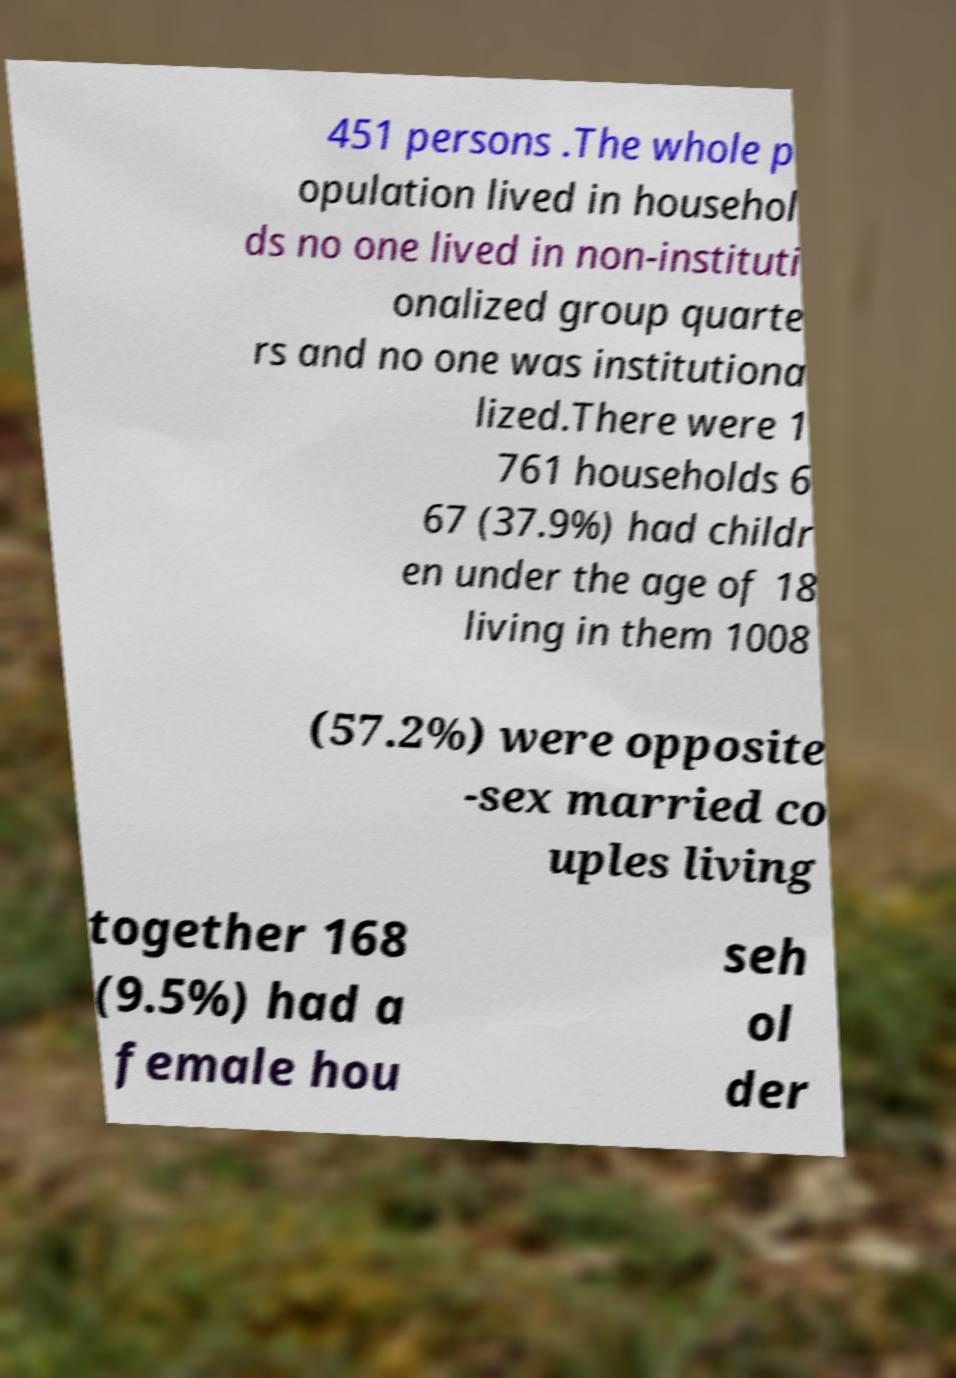Can you accurately transcribe the text from the provided image for me? 451 persons .The whole p opulation lived in househol ds no one lived in non-instituti onalized group quarte rs and no one was institutiona lized.There were 1 761 households 6 67 (37.9%) had childr en under the age of 18 living in them 1008 (57.2%) were opposite -sex married co uples living together 168 (9.5%) had a female hou seh ol der 